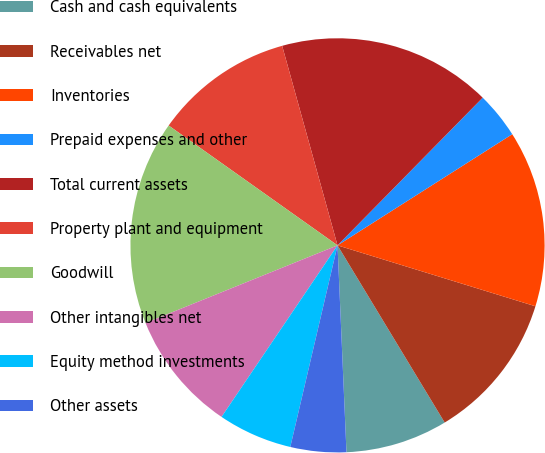<chart> <loc_0><loc_0><loc_500><loc_500><pie_chart><fcel>Cash and cash equivalents<fcel>Receivables net<fcel>Inventories<fcel>Prepaid expenses and other<fcel>Total current assets<fcel>Property plant and equipment<fcel>Goodwill<fcel>Other intangibles net<fcel>Equity method investments<fcel>Other assets<nl><fcel>7.97%<fcel>11.59%<fcel>13.77%<fcel>3.62%<fcel>16.67%<fcel>10.87%<fcel>15.94%<fcel>9.42%<fcel>5.8%<fcel>4.35%<nl></chart> 